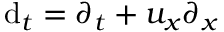<formula> <loc_0><loc_0><loc_500><loc_500>d _ { t } = \partial _ { t } + u _ { x } \partial _ { x }</formula> 